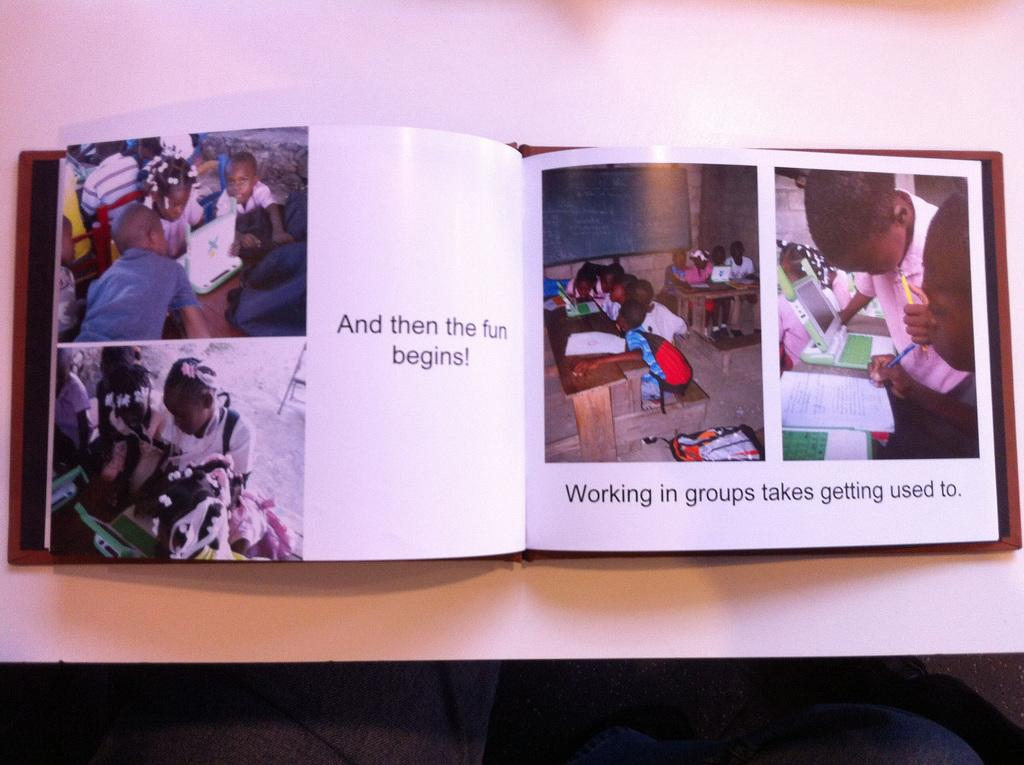<image>
Summarize the visual content of the image. My coffee table holds our family scrapbook, letting us remember that groups take getting used to 